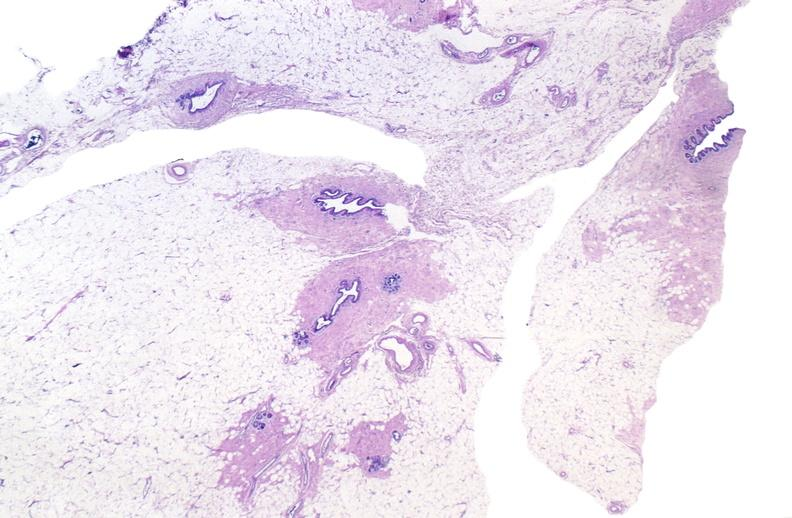where is this area in the body?
Answer the question using a single word or phrase. Breast 